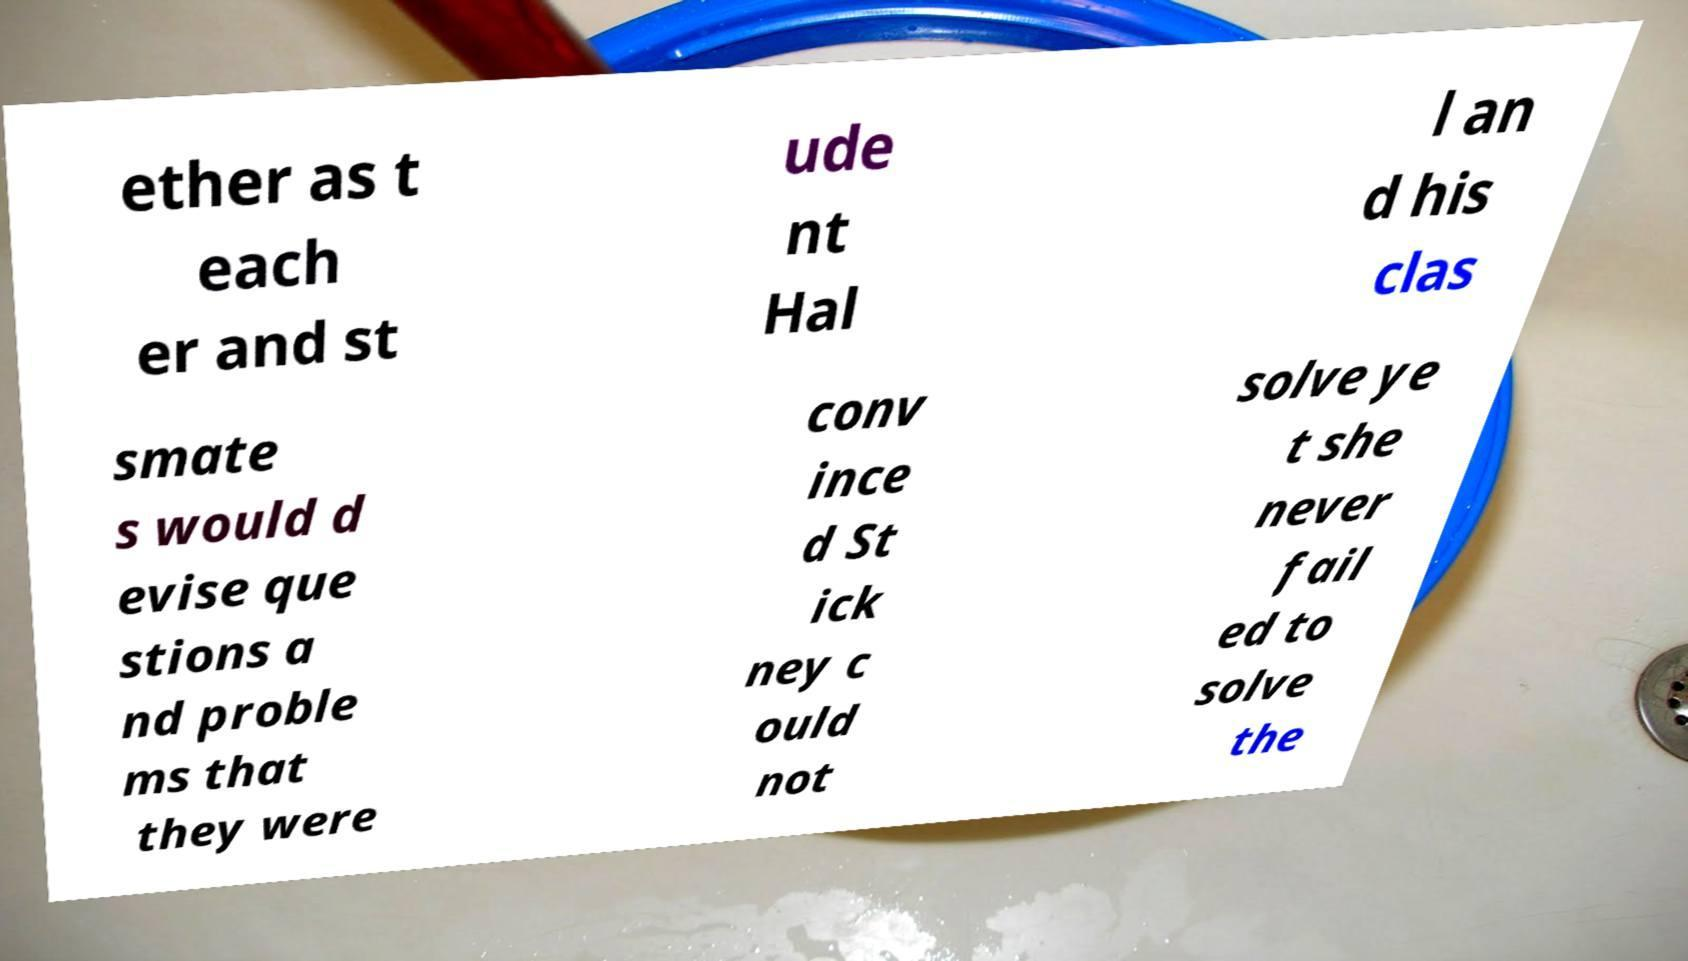Could you extract and type out the text from this image? ether as t each er and st ude nt Hal l an d his clas smate s would d evise que stions a nd proble ms that they were conv ince d St ick ney c ould not solve ye t she never fail ed to solve the 